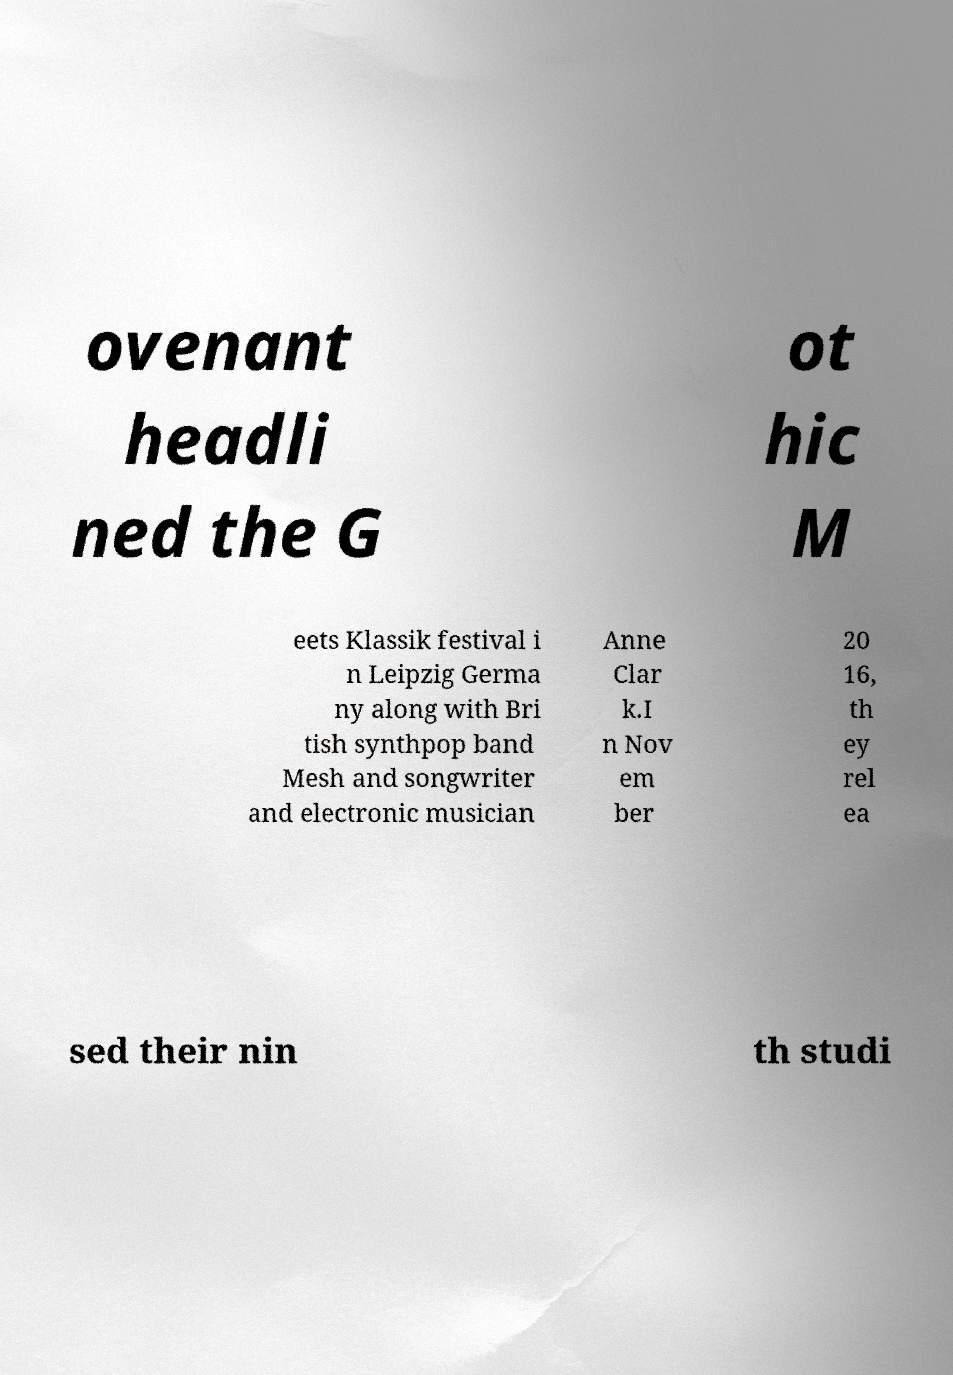Please identify and transcribe the text found in this image. ovenant headli ned the G ot hic M eets Klassik festival i n Leipzig Germa ny along with Bri tish synthpop band Mesh and songwriter and electronic musician Anne Clar k.I n Nov em ber 20 16, th ey rel ea sed their nin th studi 